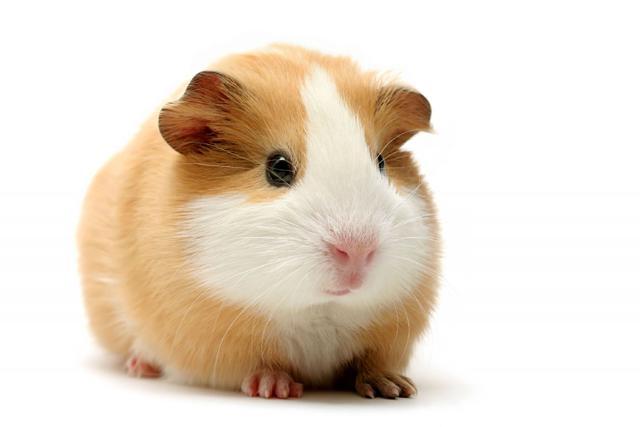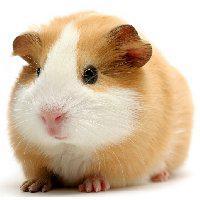The first image is the image on the left, the second image is the image on the right. For the images displayed, is the sentence "The image on the left contains food." factually correct? Answer yes or no. No. 